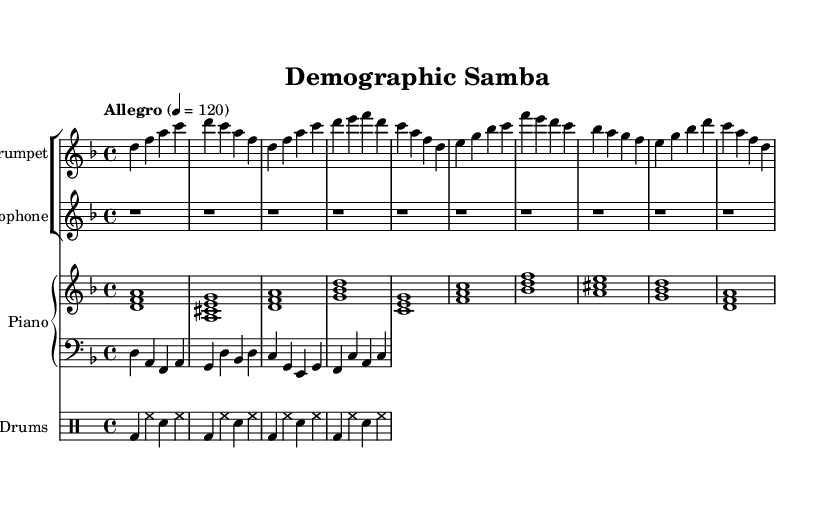What is the key signature of this music? The key signature indicates the number of sharps or flats in the piece. In this case, the key signature is D minor, which has one flat (B flat).
Answer: D minor What is the time signature of this piece? The time signature is typically displayed at the beginning of the score and indicates how many beats are in each measure as well as what note value counts as one beat. Here, the time signature is 4/4, meaning there are four beats per measure and the quarter note gets one beat.
Answer: 4/4 What is the tempo marking for this composition? The tempo marking is usually indicated at the beginning, alongside the time signature. It shows how fast or slow the piece should be played. The tempo for this composition is marked as "Allegro," which means fast. Additionally, a specific beats-per-minute (bpm) number of 120 is given.
Answer: Allegro, 120 Which instruments are part of this composition? The score lists several staves, each representing a different instrument played in the piece. The instruments present in this composition are Trumpet, Saxophone, Piano (with Bass part), and Drums.
Answer: Trumpet, Saxophone, Piano, Drums How many measures are in the A section? The A section spans eight measures in total, as indicated by the sequence of musical phrases written out. Each section of the scored music can be clearly counted.
Answer: 8 What style is this composition indicative of? The overall rhythmic and harmonic structure, along with the instrumentation, suggests a Latin jazz style, which often combines jazz with Latin rhythms. The lively tempo and syncopated rhythms typical of samba rhythms further affirm this classification.
Answer: Latin jazz 